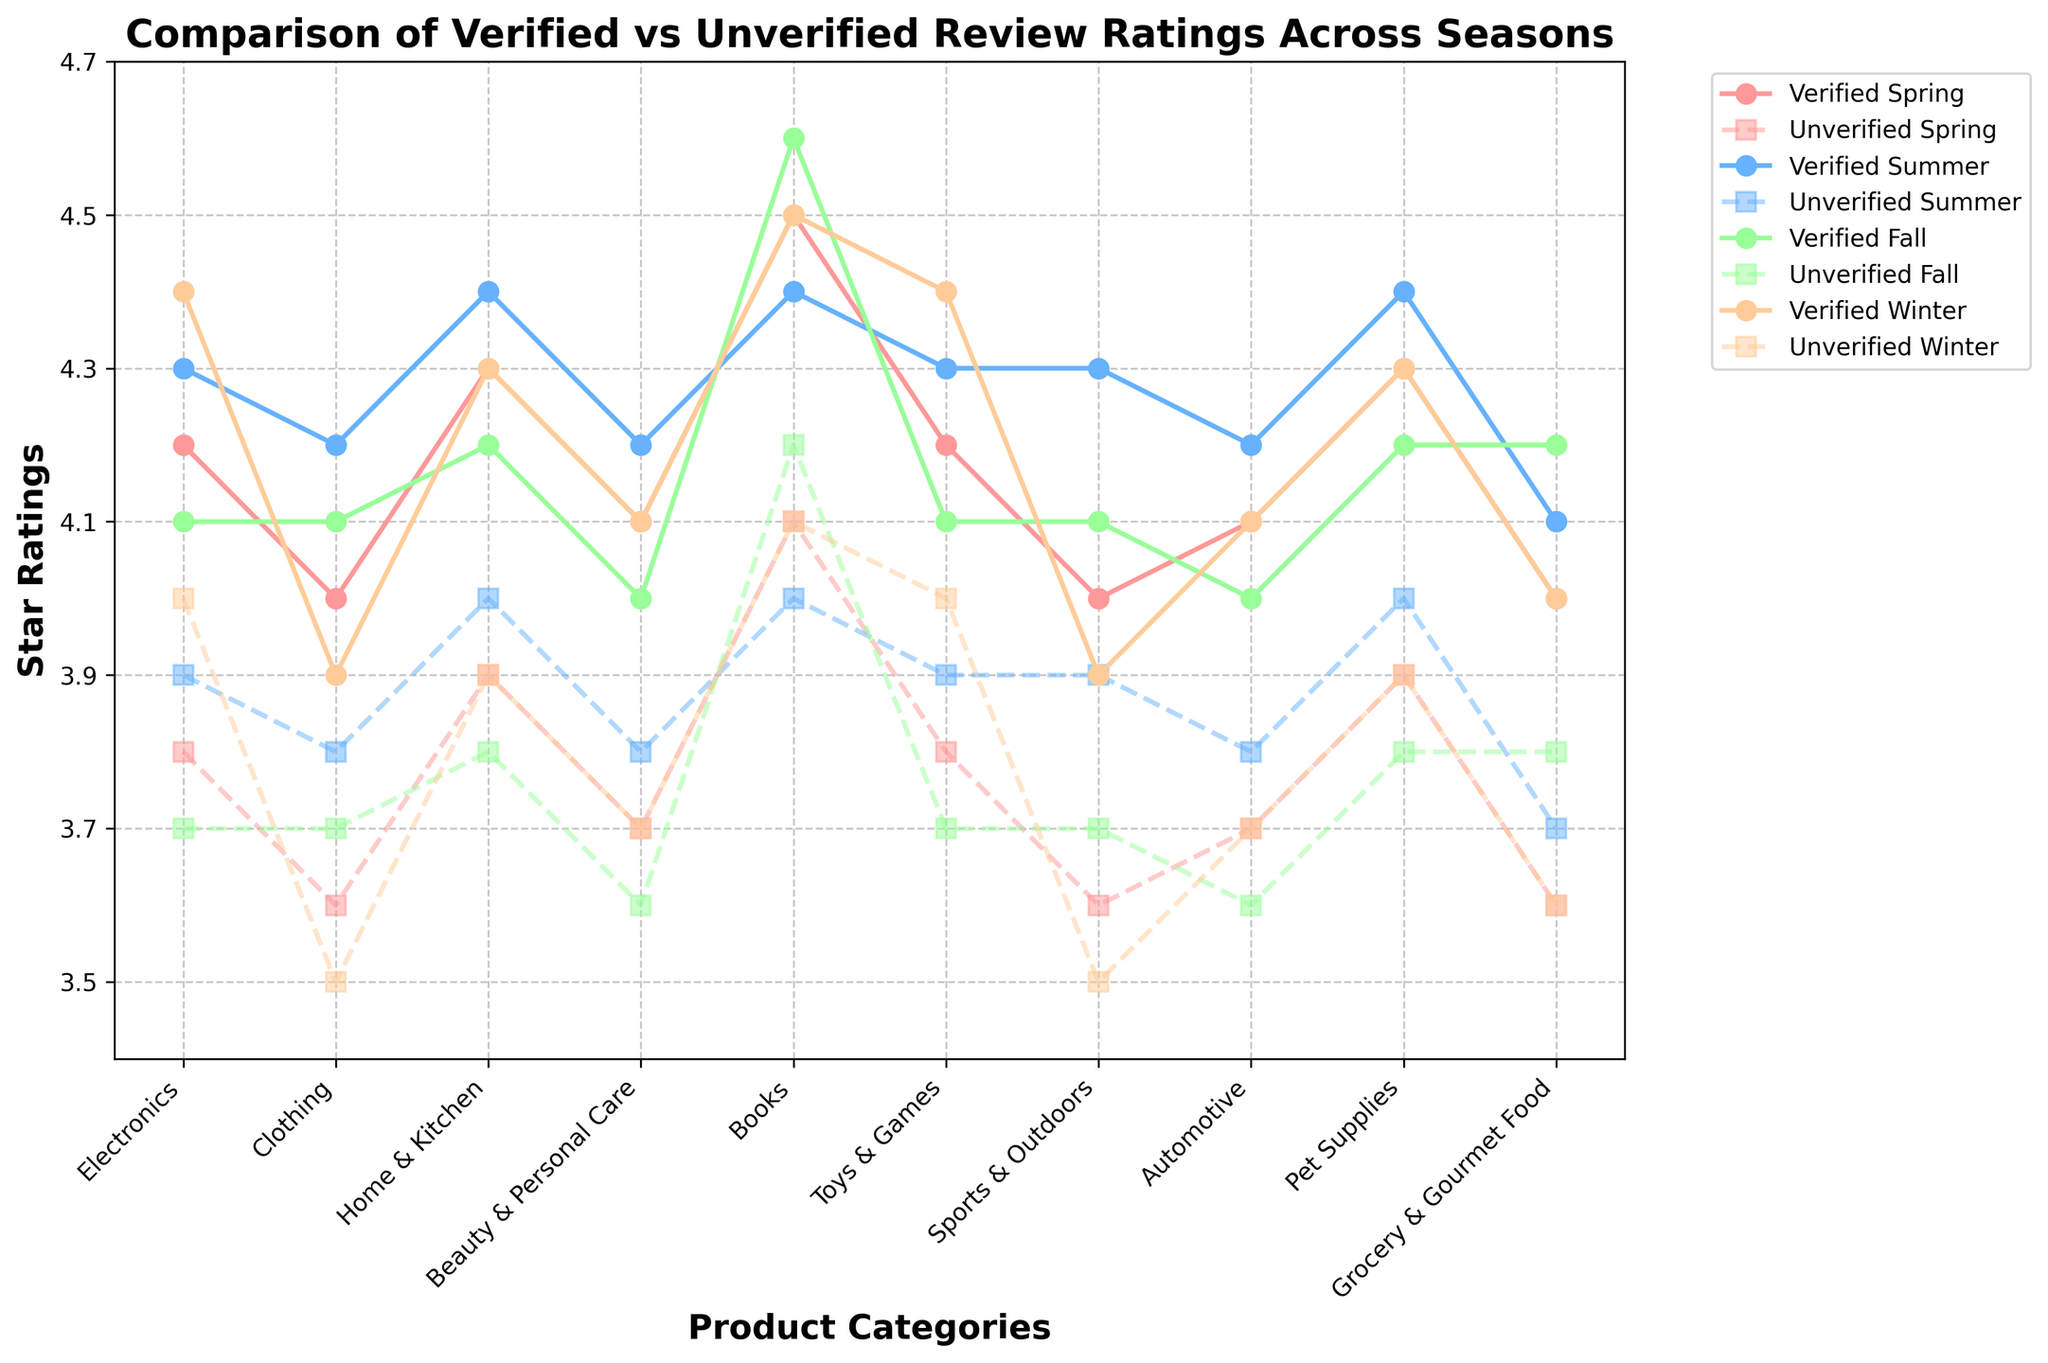Which season has the highest average star rating for verified reviews across all categories? To find the highest average star rating for verified reviews across all categories, we average the ratings for each season:
- Spring: (4.2 + 4.0 + 4.3 + 4.1 + 4.5 + 4.2 + 4.0 + 4.1 + 4.3 + 4.0) / 10 = 4.17
- Summer: (4.3 + 4.2 + 4.4 + 4.2 + 4.4 + 4.3 + 4.3 + 4.2 + 4.4 + 4.1) / 10 = 4.28
- Fall: (4.1 + 4.1 + 4.2 + 4.0 + 4.6 + 4.1 + 4.1 + 4.0 + 4.2 + 4.2) / 10 = 4.18
- Winter: (4.4 + 3.9 + 4.3 + 4.1 + 4.5 + 4.4 + 3.9 + 4.1 + 4.3 + 4.0) / 10 = 4.19
- Summer has the highest average rating
Answer: Summer Which product category has the smallest gap between verified and unverified reviews in Winter? To identify the smallest gap between verified and unverified winter reviews, calculate the differences for each category:
- Electronics: 4.4 - 4.0 = 0.4
- Clothing: 3.9 - 3.5 = 0.4
- Home & Kitchen: 4.3 - 3.9 = 0.4
- Beauty & Personal Care: 4.1 - 3.7 = 0.4
- Books: 4.5 - 4.1 = 0.4
- Toys & Games: 4.4 - 4.0 = 0.4
- Sports & Outdoors: 3.9 - 3.5 = 0.4
- Automotive: 4.1 - 3.7 = 0.4
- Pet Supplies: 4.3 - 3.9 = 0.4
- Grocery & Gourmet Food: 4.0 - 3.6 = 0.4
- All categories have the same gap of 0.4
Answer: All Categories In which season do verified and unverified reviews for the "Books" category have the largest difference in star ratings? To find the largest difference, calculate the difference between verified and unverified ratings for each season in the Books category:
- Spring: 4.5 - 4.1 = 0.4
- Summer: 4.4 - 4.0 = 0.4
- Fall: 4.6 - 4.2 = 0.4
- Winter: 4.5 - 4.1 = 0.4
- Differences are the same across seasons
Answer: Equal What is the average rating difference between verified and unverified reviews for the "Sports & Outdoors" category across all seasons? To find the average rating difference, calculate the difference for each season and then find the average:
- Spring: 4.0 - 3.6 = 0.4
- Summer: 4.3 - 3.9 = 0.4
- Fall: 4.1 - 3.7 = 0.4
- Winter: 3.9 - 3.5 = 0.4
- Average difference: (0.4 + 0.4 + 0.4 + 0.4) / 4 = 0.4
Answer: 0.4 During which season do verified reviews of "Beauty & Personal Care" have the highest rating? Look at the verified ratings for "Beauty & Personal Care" across the four seasons:
- Spring: 4.1
- Summer: 4.2
- Fall: 4.0
- Winter: 4.1
- Summer has the highest rating
Answer: Summer 